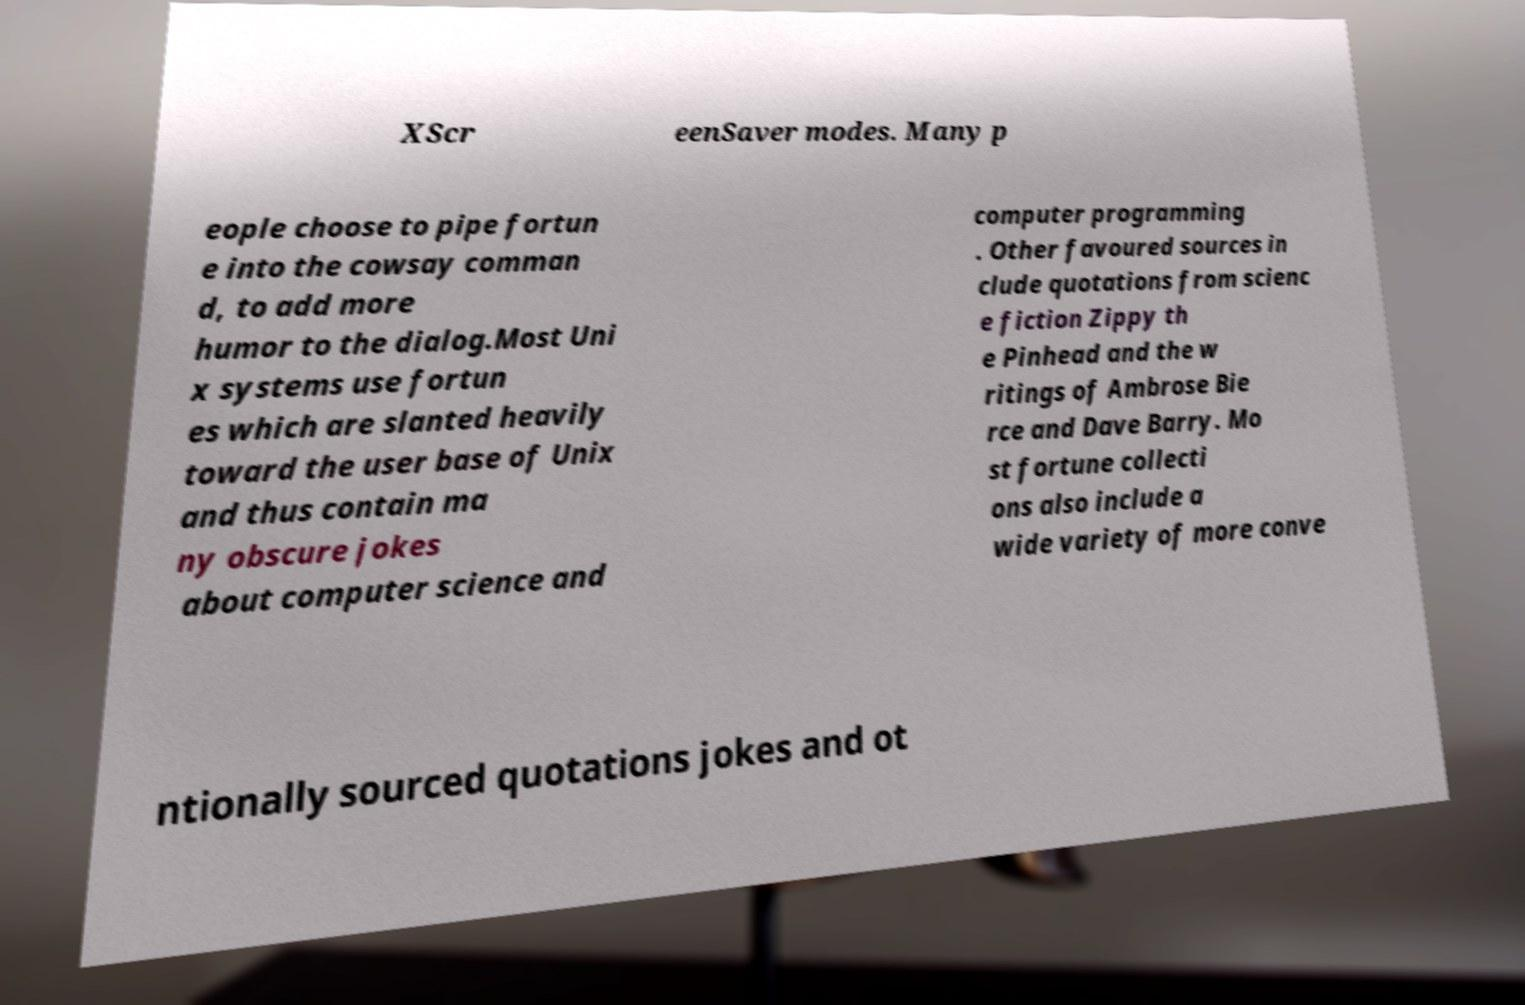Please read and relay the text visible in this image. What does it say? XScr eenSaver modes. Many p eople choose to pipe fortun e into the cowsay comman d, to add more humor to the dialog.Most Uni x systems use fortun es which are slanted heavily toward the user base of Unix and thus contain ma ny obscure jokes about computer science and computer programming . Other favoured sources in clude quotations from scienc e fiction Zippy th e Pinhead and the w ritings of Ambrose Bie rce and Dave Barry. Mo st fortune collecti ons also include a wide variety of more conve ntionally sourced quotations jokes and ot 